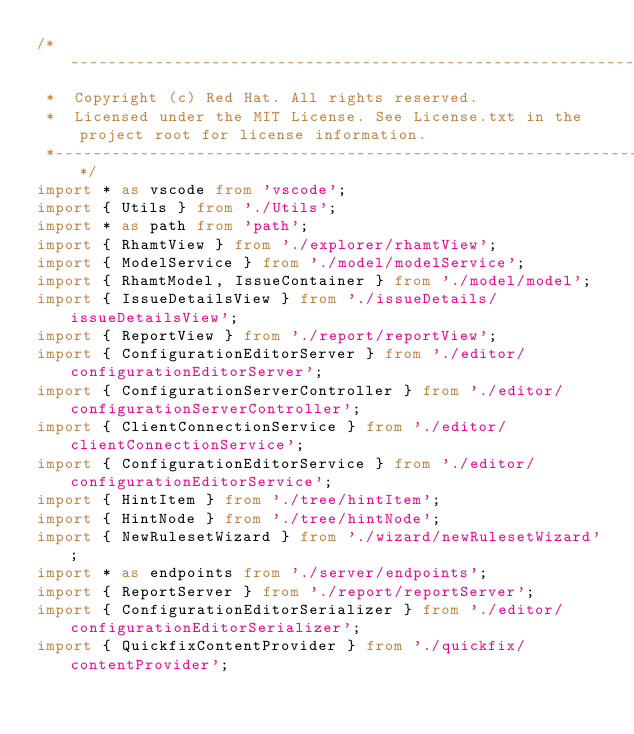<code> <loc_0><loc_0><loc_500><loc_500><_TypeScript_>/*---------------------------------------------------------------------------------------------
 *  Copyright (c) Red Hat. All rights reserved.
 *  Licensed under the MIT License. See License.txt in the project root for license information.
 *--------------------------------------------------------------------------------------------*/
import * as vscode from 'vscode';
import { Utils } from './Utils';
import * as path from 'path';
import { RhamtView } from './explorer/rhamtView';
import { ModelService } from './model/modelService';
import { RhamtModel, IssueContainer } from './model/model';
import { IssueDetailsView } from './issueDetails/issueDetailsView';
import { ReportView } from './report/reportView';
import { ConfigurationEditorServer } from './editor/configurationEditorServer';
import { ConfigurationServerController } from './editor/configurationServerController';
import { ClientConnectionService } from './editor/clientConnectionService';
import { ConfigurationEditorService } from './editor/configurationEditorService';
import { HintItem } from './tree/hintItem';
import { HintNode } from './tree/hintNode';
import { NewRulesetWizard } from './wizard/newRulesetWizard';
import * as endpoints from './server/endpoints';
import { ReportServer } from './report/reportServer';
import { ConfigurationEditorSerializer } from './editor/configurationEditorSerializer';
import { QuickfixContentProvider } from './quickfix/contentProvider';</code> 